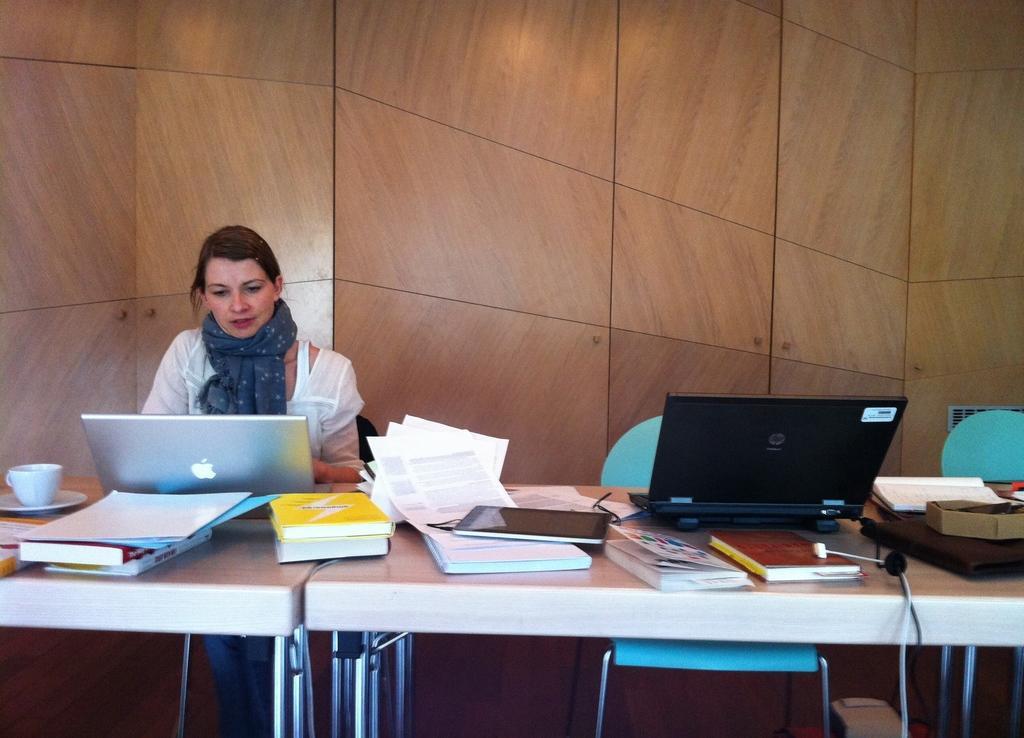Could you give a brief overview of what you see in this image? As we can see in the image there is a women sitting on chair and there is a table over here. On table there are laptops, books, papers and tablet. 